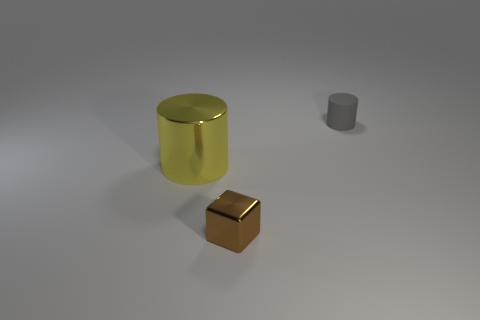There is another gray rubber thing that is the same shape as the big thing; what size is it?
Give a very brief answer. Small. Are any gray things visible?
Provide a short and direct response. Yes. How many objects are objects that are on the right side of the large yellow cylinder or yellow cylinders?
Provide a short and direct response. 3. What material is the gray object that is the same size as the brown cube?
Make the answer very short. Rubber. The tiny thing that is behind the small thing that is to the left of the rubber object is what color?
Keep it short and to the point. Gray. How many tiny brown cubes are behind the brown shiny object?
Keep it short and to the point. 0. The big shiny object is what color?
Your answer should be compact. Yellow. What number of big things are either brown blocks or purple rubber spheres?
Offer a terse response. 0. Is the color of the cylinder that is in front of the gray thing the same as the tiny object on the left side of the gray rubber cylinder?
Provide a succinct answer. No. What number of other objects are there of the same color as the small cylinder?
Give a very brief answer. 0. 